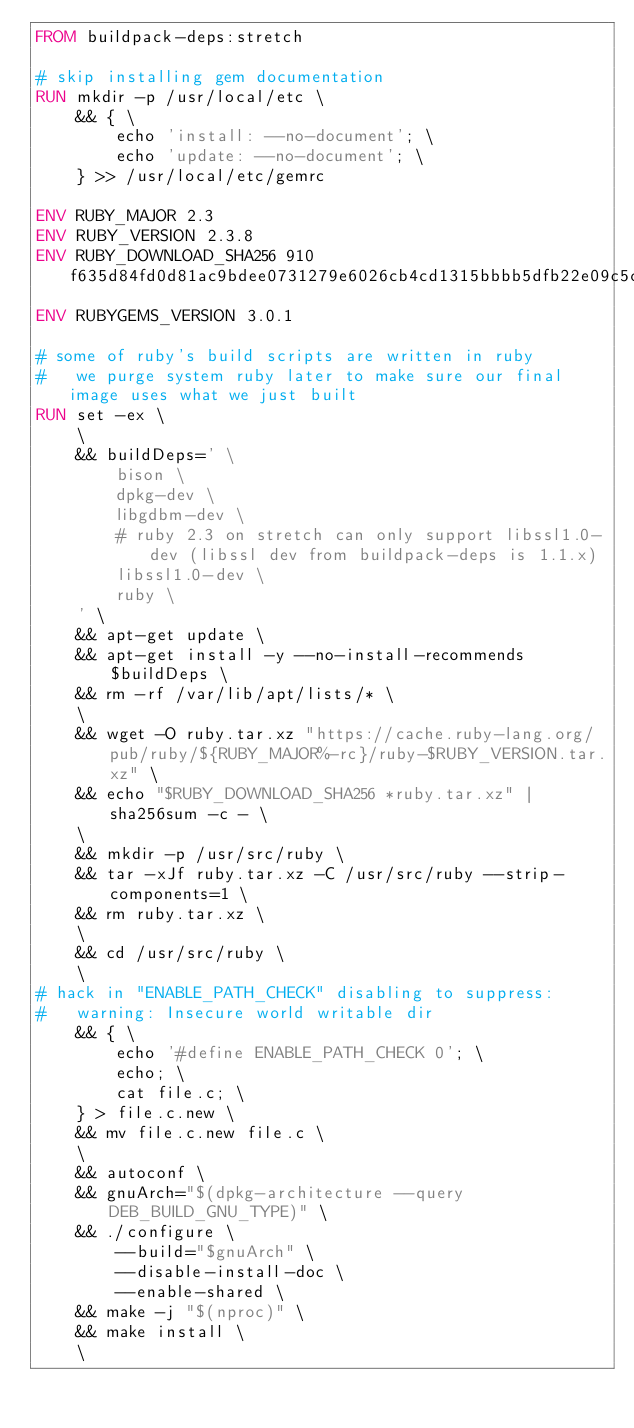<code> <loc_0><loc_0><loc_500><loc_500><_Dockerfile_>FROM buildpack-deps:stretch

# skip installing gem documentation
RUN mkdir -p /usr/local/etc \
	&& { \
		echo 'install: --no-document'; \
		echo 'update: --no-document'; \
	} >> /usr/local/etc/gemrc

ENV RUBY_MAJOR 2.3
ENV RUBY_VERSION 2.3.8
ENV RUBY_DOWNLOAD_SHA256 910f635d84fd0d81ac9bdee0731279e6026cb4cd1315bbbb5dfb22e09c5c1dfe
ENV RUBYGEMS_VERSION 3.0.1

# some of ruby's build scripts are written in ruby
#   we purge system ruby later to make sure our final image uses what we just built
RUN set -ex \
	\
	&& buildDeps=' \
		bison \
		dpkg-dev \
		libgdbm-dev \
		# ruby 2.3 on stretch can only support libssl1.0-dev (libssl dev from buildpack-deps is 1.1.x)
		libssl1.0-dev \
		ruby \
	' \
	&& apt-get update \
	&& apt-get install -y --no-install-recommends $buildDeps \
	&& rm -rf /var/lib/apt/lists/* \
	\
	&& wget -O ruby.tar.xz "https://cache.ruby-lang.org/pub/ruby/${RUBY_MAJOR%-rc}/ruby-$RUBY_VERSION.tar.xz" \
	&& echo "$RUBY_DOWNLOAD_SHA256 *ruby.tar.xz" | sha256sum -c - \
	\
	&& mkdir -p /usr/src/ruby \
	&& tar -xJf ruby.tar.xz -C /usr/src/ruby --strip-components=1 \
	&& rm ruby.tar.xz \
	\
	&& cd /usr/src/ruby \
	\
# hack in "ENABLE_PATH_CHECK" disabling to suppress:
#   warning: Insecure world writable dir
	&& { \
		echo '#define ENABLE_PATH_CHECK 0'; \
		echo; \
		cat file.c; \
	} > file.c.new \
	&& mv file.c.new file.c \
	\
	&& autoconf \
	&& gnuArch="$(dpkg-architecture --query DEB_BUILD_GNU_TYPE)" \
	&& ./configure \
		--build="$gnuArch" \
		--disable-install-doc \
		--enable-shared \
	&& make -j "$(nproc)" \
	&& make install \
	\</code> 